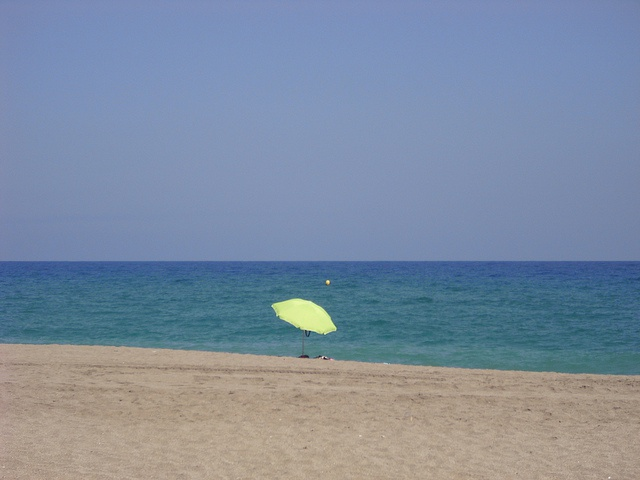Describe the objects in this image and their specific colors. I can see a umbrella in gray, khaki, and lightgreen tones in this image. 